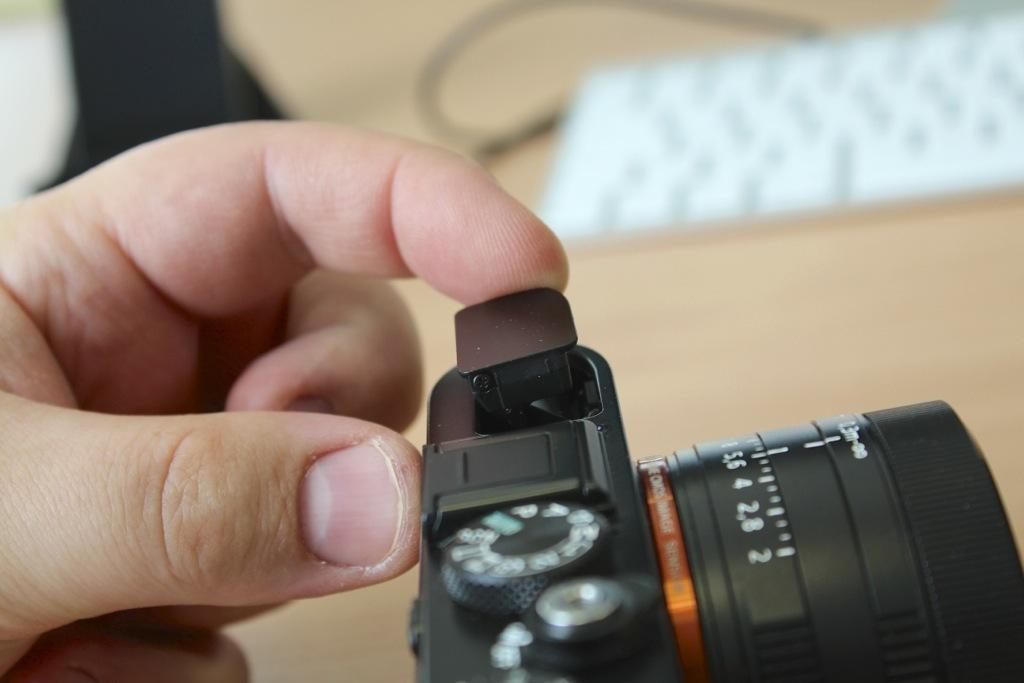In one or two sentences, can you explain what this image depicts? In this image, we can see a black color camera and there is a hand of a person, there is a blur background. 